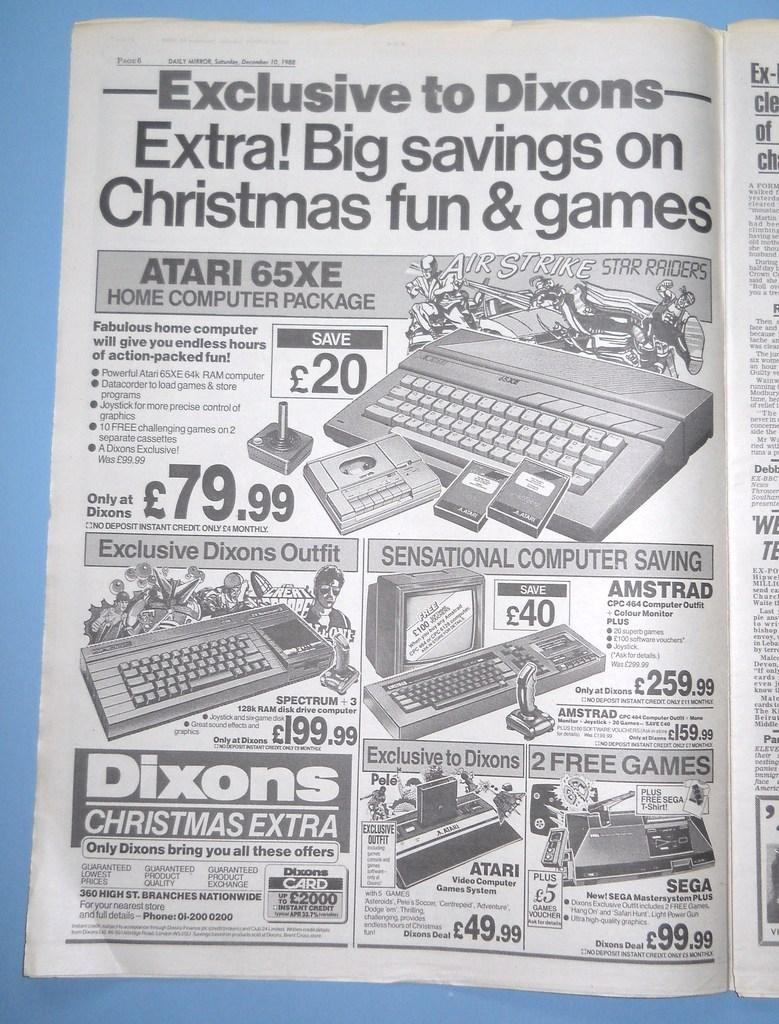Provide a one-sentence caption for the provided image. A magazine with the page "Exclusive to Dixons" as the headline. 